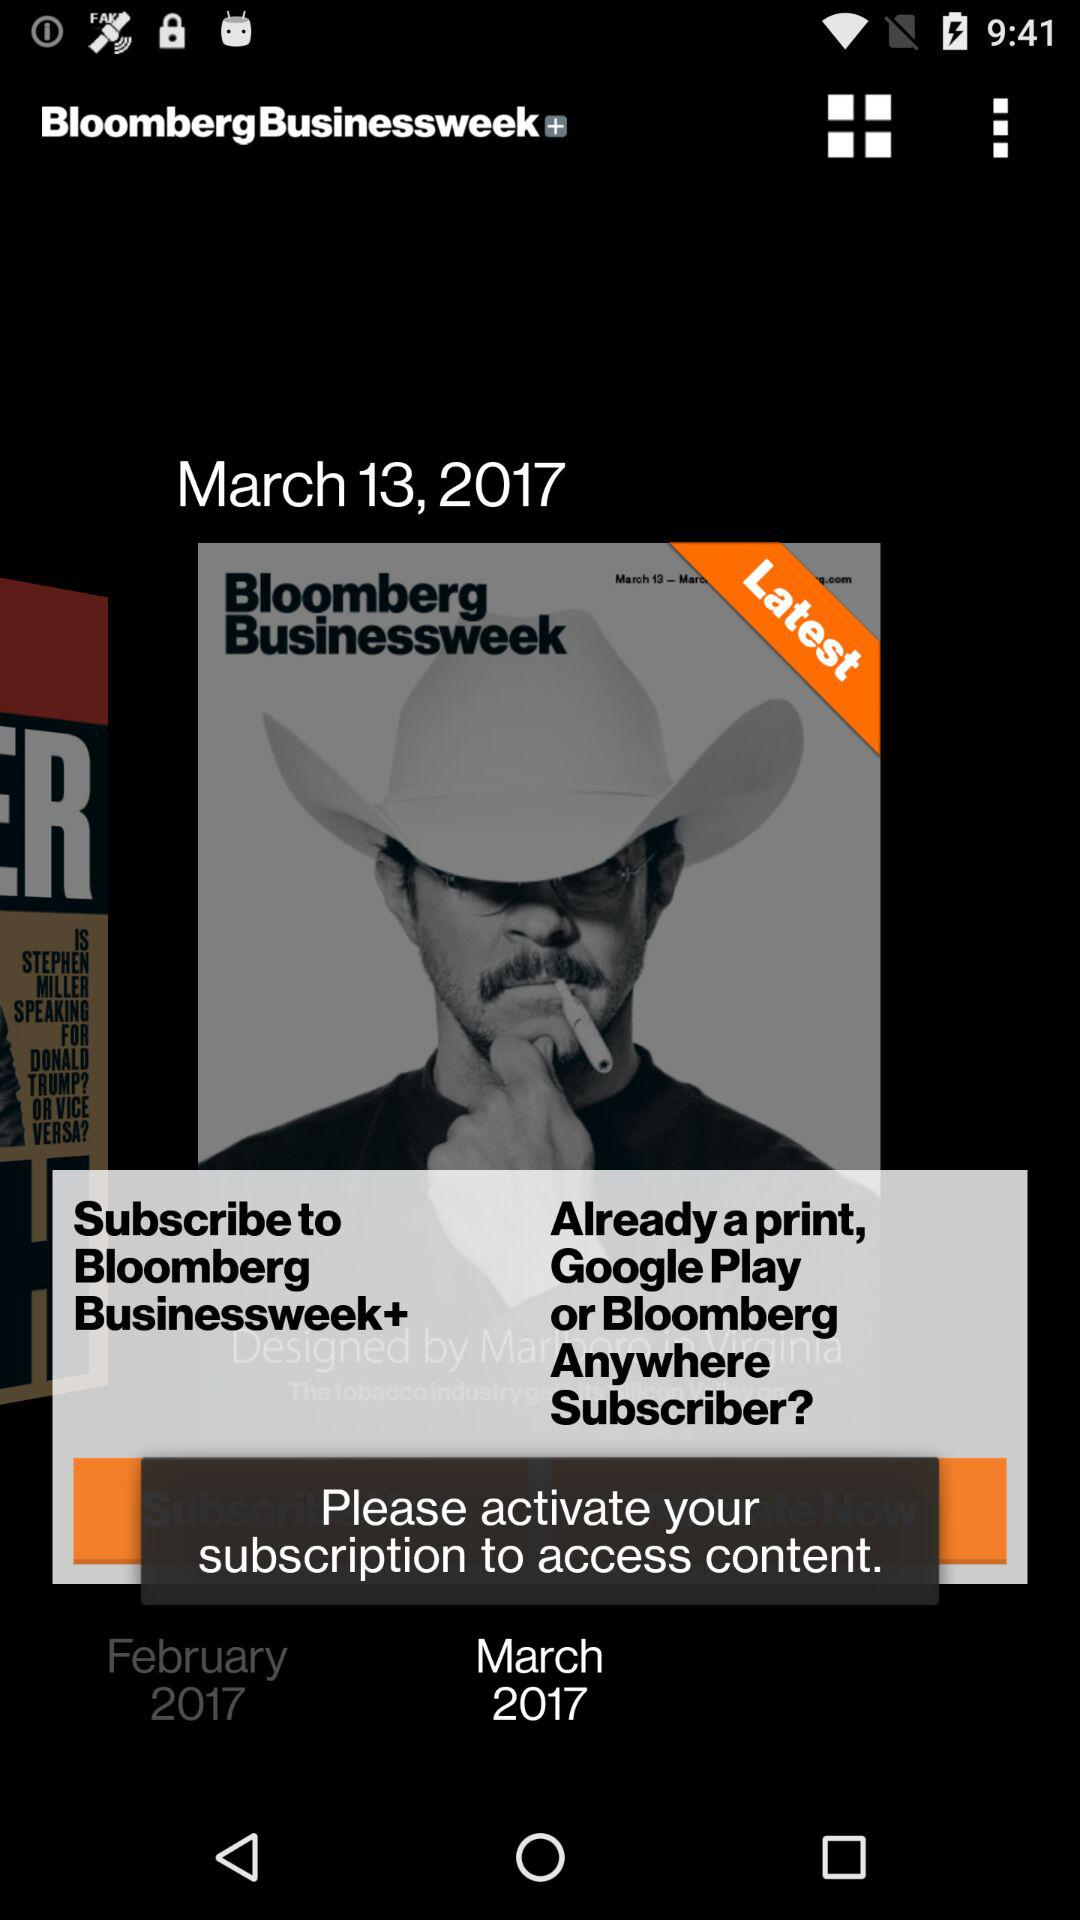What is the date? The date is March 13, 2017. 